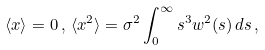<formula> <loc_0><loc_0><loc_500><loc_500>\langle x \rangle = 0 \, , \, \langle x ^ { 2 } \rangle = \sigma ^ { 2 } \int _ { 0 } ^ { \infty } s ^ { 3 } w ^ { 2 } ( s ) \, d s \, ,</formula> 